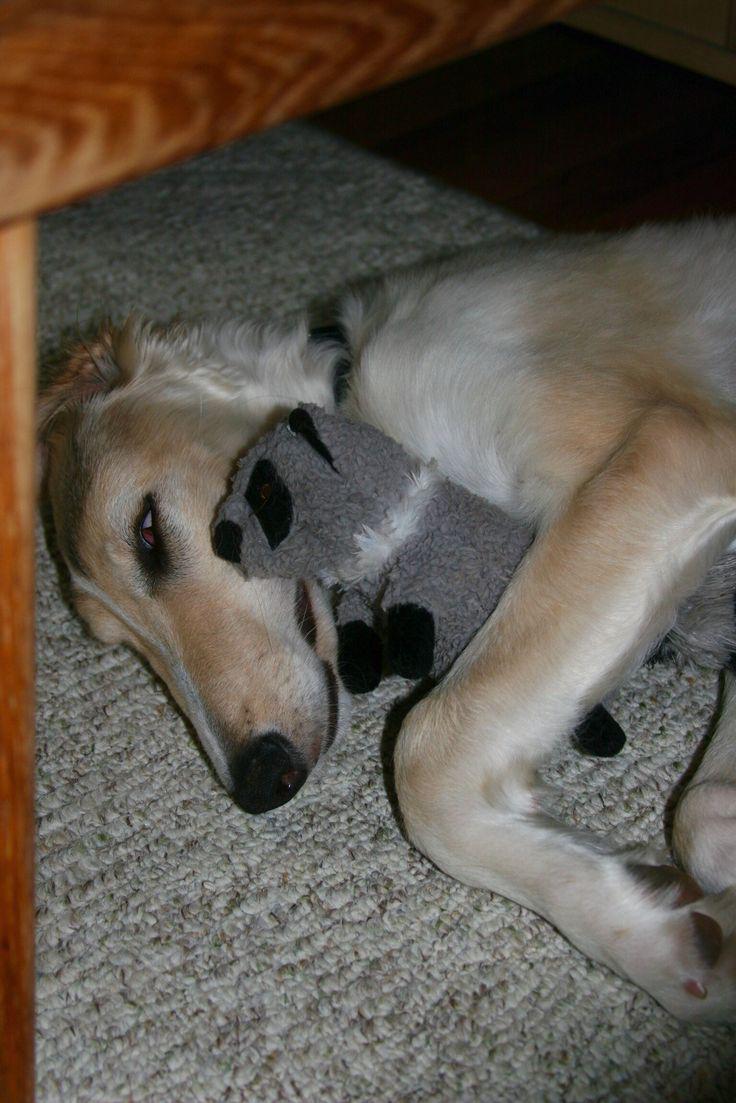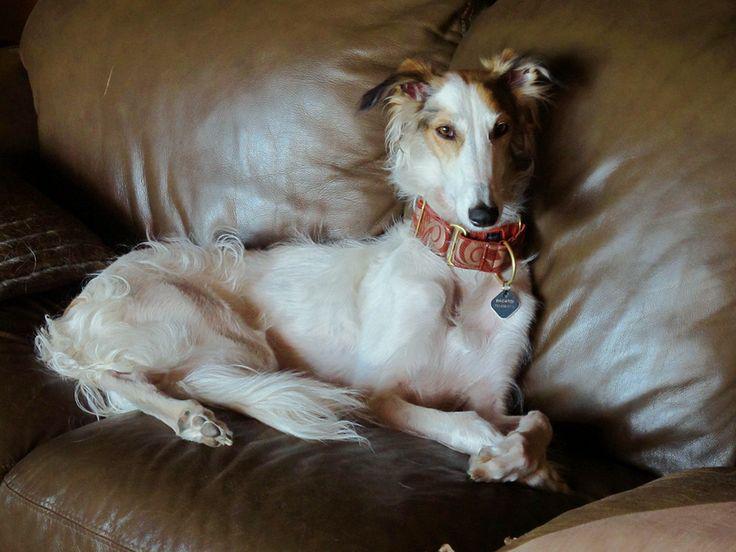The first image is the image on the left, the second image is the image on the right. Given the left and right images, does the statement "Each image shows a hound lounging on upholstered furniture, and one image shows a hound upside-down with hind legs above his front paws." hold true? Answer yes or no. No. The first image is the image on the left, the second image is the image on the right. Analyze the images presented: Is the assertion "At least one dog is laying on his back." valid? Answer yes or no. No. 